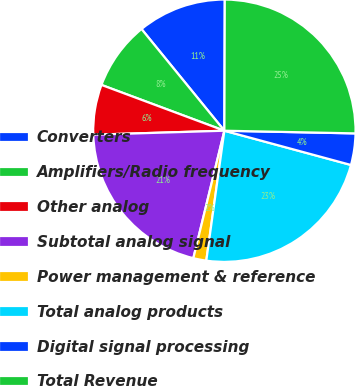<chart> <loc_0><loc_0><loc_500><loc_500><pie_chart><fcel>Converters<fcel>Amplifiers/Radio frequency<fcel>Other analog<fcel>Subtotal analog signal<fcel>Power management & reference<fcel>Total analog products<fcel>Digital signal processing<fcel>Total Revenue<nl><fcel>10.93%<fcel>8.44%<fcel>6.16%<fcel>20.71%<fcel>1.6%<fcel>22.99%<fcel>3.88%<fcel>25.27%<nl></chart> 